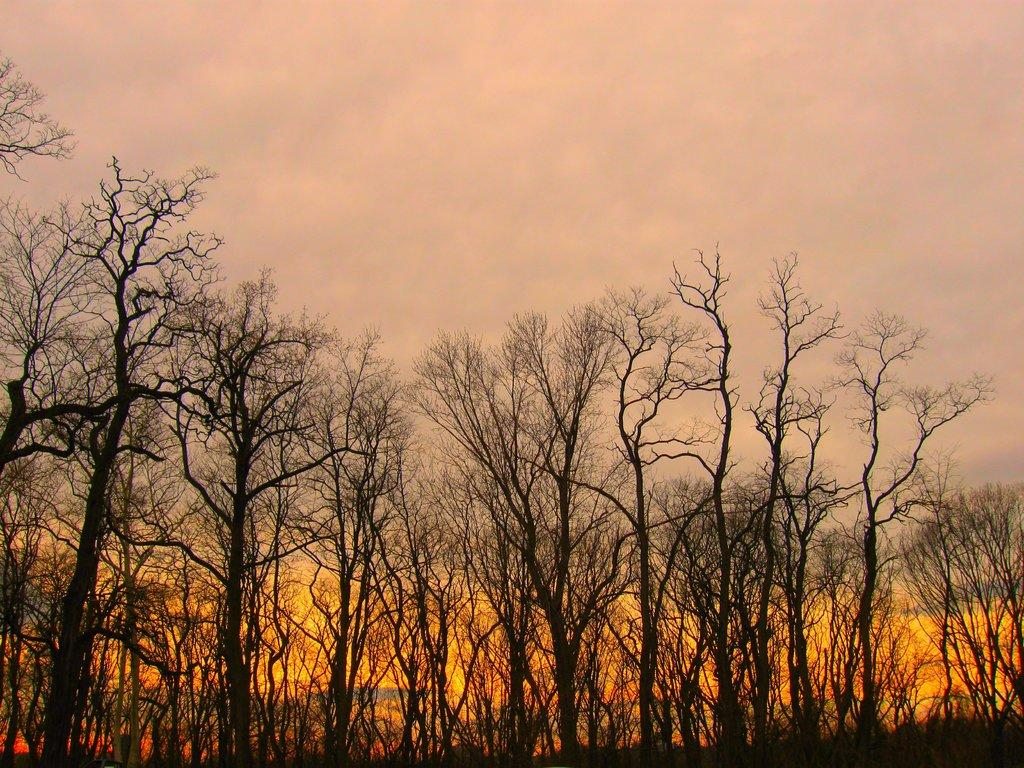What type of natural elements can be seen in the image? There are many trees in the image. What is the condition of the sky in the image? The sky is clouded in the image. What type of adjustment can be seen on the trees in the image? There is no specific adjustment visible on the trees in the image; they are simply trees. 